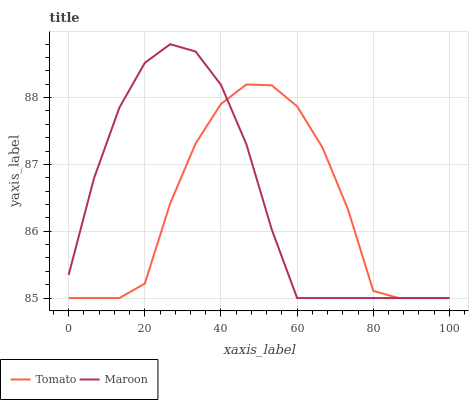Does Tomato have the minimum area under the curve?
Answer yes or no. Yes. Does Maroon have the maximum area under the curve?
Answer yes or no. Yes. Does Maroon have the minimum area under the curve?
Answer yes or no. No. Is Maroon the smoothest?
Answer yes or no. Yes. Is Tomato the roughest?
Answer yes or no. Yes. Is Maroon the roughest?
Answer yes or no. No. Does Tomato have the lowest value?
Answer yes or no. Yes. Does Maroon have the highest value?
Answer yes or no. Yes. Does Tomato intersect Maroon?
Answer yes or no. Yes. Is Tomato less than Maroon?
Answer yes or no. No. Is Tomato greater than Maroon?
Answer yes or no. No. 